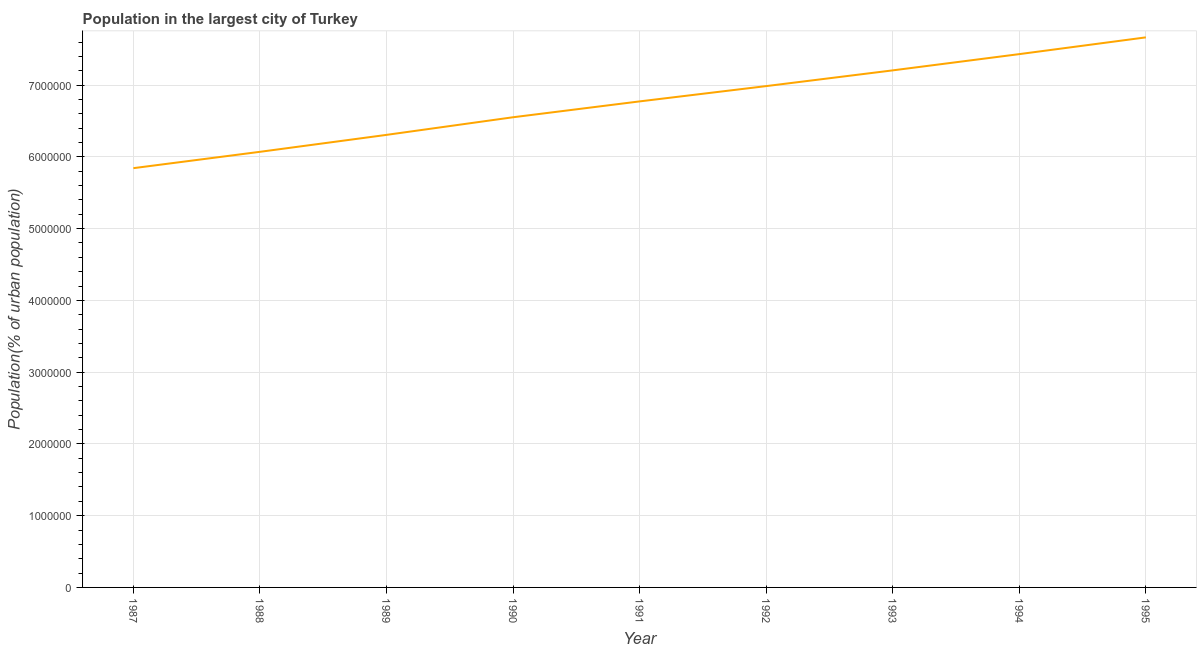What is the population in largest city in 1995?
Your answer should be compact. 7.67e+06. Across all years, what is the maximum population in largest city?
Offer a very short reply. 7.67e+06. Across all years, what is the minimum population in largest city?
Make the answer very short. 5.84e+06. In which year was the population in largest city maximum?
Your answer should be very brief. 1995. In which year was the population in largest city minimum?
Your answer should be very brief. 1987. What is the sum of the population in largest city?
Offer a very short reply. 6.08e+07. What is the difference between the population in largest city in 1990 and 1993?
Offer a very short reply. -6.53e+05. What is the average population in largest city per year?
Your answer should be compact. 6.76e+06. What is the median population in largest city?
Keep it short and to the point. 6.77e+06. Do a majority of the years between 1990 and 1991 (inclusive) have population in largest city greater than 6800000 %?
Ensure brevity in your answer.  No. What is the ratio of the population in largest city in 1992 to that in 1994?
Ensure brevity in your answer.  0.94. Is the difference between the population in largest city in 1988 and 1994 greater than the difference between any two years?
Your response must be concise. No. What is the difference between the highest and the second highest population in largest city?
Ensure brevity in your answer.  2.34e+05. Is the sum of the population in largest city in 1988 and 1993 greater than the maximum population in largest city across all years?
Give a very brief answer. Yes. What is the difference between the highest and the lowest population in largest city?
Your response must be concise. 1.82e+06. In how many years, is the population in largest city greater than the average population in largest city taken over all years?
Give a very brief answer. 5. Does the population in largest city monotonically increase over the years?
Ensure brevity in your answer.  Yes. How many years are there in the graph?
Offer a very short reply. 9. What is the difference between two consecutive major ticks on the Y-axis?
Ensure brevity in your answer.  1.00e+06. Does the graph contain grids?
Offer a very short reply. Yes. What is the title of the graph?
Ensure brevity in your answer.  Population in the largest city of Turkey. What is the label or title of the Y-axis?
Offer a very short reply. Population(% of urban population). What is the Population(% of urban population) in 1987?
Your answer should be compact. 5.84e+06. What is the Population(% of urban population) in 1988?
Offer a very short reply. 6.07e+06. What is the Population(% of urban population) of 1989?
Your answer should be very brief. 6.31e+06. What is the Population(% of urban population) of 1990?
Your response must be concise. 6.55e+06. What is the Population(% of urban population) in 1991?
Provide a succinct answer. 6.77e+06. What is the Population(% of urban population) of 1992?
Your response must be concise. 6.99e+06. What is the Population(% of urban population) of 1993?
Give a very brief answer. 7.21e+06. What is the Population(% of urban population) in 1994?
Provide a short and direct response. 7.43e+06. What is the Population(% of urban population) in 1995?
Your response must be concise. 7.67e+06. What is the difference between the Population(% of urban population) in 1987 and 1988?
Your answer should be very brief. -2.28e+05. What is the difference between the Population(% of urban population) in 1987 and 1989?
Your answer should be very brief. -4.64e+05. What is the difference between the Population(% of urban population) in 1987 and 1990?
Keep it short and to the point. -7.10e+05. What is the difference between the Population(% of urban population) in 1987 and 1991?
Ensure brevity in your answer.  -9.31e+05. What is the difference between the Population(% of urban population) in 1987 and 1992?
Your answer should be very brief. -1.14e+06. What is the difference between the Population(% of urban population) in 1987 and 1993?
Make the answer very short. -1.36e+06. What is the difference between the Population(% of urban population) in 1987 and 1994?
Offer a very short reply. -1.59e+06. What is the difference between the Population(% of urban population) in 1987 and 1995?
Provide a short and direct response. -1.82e+06. What is the difference between the Population(% of urban population) in 1988 and 1989?
Give a very brief answer. -2.36e+05. What is the difference between the Population(% of urban population) in 1988 and 1990?
Make the answer very short. -4.82e+05. What is the difference between the Population(% of urban population) in 1988 and 1991?
Your answer should be very brief. -7.03e+05. What is the difference between the Population(% of urban population) in 1988 and 1992?
Ensure brevity in your answer.  -9.16e+05. What is the difference between the Population(% of urban population) in 1988 and 1993?
Ensure brevity in your answer.  -1.14e+06. What is the difference between the Population(% of urban population) in 1988 and 1994?
Provide a succinct answer. -1.36e+06. What is the difference between the Population(% of urban population) in 1988 and 1995?
Keep it short and to the point. -1.59e+06. What is the difference between the Population(% of urban population) in 1989 and 1990?
Your answer should be very brief. -2.46e+05. What is the difference between the Population(% of urban population) in 1989 and 1991?
Keep it short and to the point. -4.67e+05. What is the difference between the Population(% of urban population) in 1989 and 1992?
Offer a terse response. -6.80e+05. What is the difference between the Population(% of urban population) in 1989 and 1993?
Keep it short and to the point. -8.99e+05. What is the difference between the Population(% of urban population) in 1989 and 1994?
Your answer should be compact. -1.13e+06. What is the difference between the Population(% of urban population) in 1989 and 1995?
Give a very brief answer. -1.36e+06. What is the difference between the Population(% of urban population) in 1990 and 1991?
Your answer should be very brief. -2.21e+05. What is the difference between the Population(% of urban population) in 1990 and 1992?
Ensure brevity in your answer.  -4.34e+05. What is the difference between the Population(% of urban population) in 1990 and 1993?
Ensure brevity in your answer.  -6.53e+05. What is the difference between the Population(% of urban population) in 1990 and 1994?
Your answer should be very brief. -8.80e+05. What is the difference between the Population(% of urban population) in 1990 and 1995?
Offer a terse response. -1.11e+06. What is the difference between the Population(% of urban population) in 1991 and 1992?
Provide a short and direct response. -2.13e+05. What is the difference between the Population(% of urban population) in 1991 and 1993?
Make the answer very short. -4.32e+05. What is the difference between the Population(% of urban population) in 1991 and 1994?
Your answer should be compact. -6.59e+05. What is the difference between the Population(% of urban population) in 1991 and 1995?
Your response must be concise. -8.92e+05. What is the difference between the Population(% of urban population) in 1992 and 1993?
Provide a short and direct response. -2.19e+05. What is the difference between the Population(% of urban population) in 1992 and 1994?
Ensure brevity in your answer.  -4.46e+05. What is the difference between the Population(% of urban population) in 1992 and 1995?
Keep it short and to the point. -6.79e+05. What is the difference between the Population(% of urban population) in 1993 and 1994?
Make the answer very short. -2.26e+05. What is the difference between the Population(% of urban population) in 1993 and 1995?
Your answer should be compact. -4.60e+05. What is the difference between the Population(% of urban population) in 1994 and 1995?
Make the answer very short. -2.34e+05. What is the ratio of the Population(% of urban population) in 1987 to that in 1989?
Make the answer very short. 0.93. What is the ratio of the Population(% of urban population) in 1987 to that in 1990?
Offer a very short reply. 0.89. What is the ratio of the Population(% of urban population) in 1987 to that in 1991?
Give a very brief answer. 0.86. What is the ratio of the Population(% of urban population) in 1987 to that in 1992?
Your answer should be compact. 0.84. What is the ratio of the Population(% of urban population) in 1987 to that in 1993?
Your answer should be very brief. 0.81. What is the ratio of the Population(% of urban population) in 1987 to that in 1994?
Offer a very short reply. 0.79. What is the ratio of the Population(% of urban population) in 1987 to that in 1995?
Make the answer very short. 0.76. What is the ratio of the Population(% of urban population) in 1988 to that in 1989?
Provide a succinct answer. 0.96. What is the ratio of the Population(% of urban population) in 1988 to that in 1990?
Make the answer very short. 0.93. What is the ratio of the Population(% of urban population) in 1988 to that in 1991?
Your answer should be very brief. 0.9. What is the ratio of the Population(% of urban population) in 1988 to that in 1992?
Keep it short and to the point. 0.87. What is the ratio of the Population(% of urban population) in 1988 to that in 1993?
Keep it short and to the point. 0.84. What is the ratio of the Population(% of urban population) in 1988 to that in 1994?
Offer a very short reply. 0.82. What is the ratio of the Population(% of urban population) in 1988 to that in 1995?
Provide a succinct answer. 0.79. What is the ratio of the Population(% of urban population) in 1989 to that in 1990?
Provide a short and direct response. 0.96. What is the ratio of the Population(% of urban population) in 1989 to that in 1991?
Ensure brevity in your answer.  0.93. What is the ratio of the Population(% of urban population) in 1989 to that in 1992?
Offer a very short reply. 0.9. What is the ratio of the Population(% of urban population) in 1989 to that in 1993?
Provide a short and direct response. 0.88. What is the ratio of the Population(% of urban population) in 1989 to that in 1994?
Offer a terse response. 0.85. What is the ratio of the Population(% of urban population) in 1989 to that in 1995?
Make the answer very short. 0.82. What is the ratio of the Population(% of urban population) in 1990 to that in 1992?
Make the answer very short. 0.94. What is the ratio of the Population(% of urban population) in 1990 to that in 1993?
Ensure brevity in your answer.  0.91. What is the ratio of the Population(% of urban population) in 1990 to that in 1994?
Offer a very short reply. 0.88. What is the ratio of the Population(% of urban population) in 1990 to that in 1995?
Keep it short and to the point. 0.85. What is the ratio of the Population(% of urban population) in 1991 to that in 1994?
Keep it short and to the point. 0.91. What is the ratio of the Population(% of urban population) in 1991 to that in 1995?
Your answer should be very brief. 0.88. What is the ratio of the Population(% of urban population) in 1992 to that in 1993?
Provide a succinct answer. 0.97. What is the ratio of the Population(% of urban population) in 1992 to that in 1995?
Provide a succinct answer. 0.91. What is the ratio of the Population(% of urban population) in 1993 to that in 1994?
Offer a very short reply. 0.97. What is the ratio of the Population(% of urban population) in 1993 to that in 1995?
Offer a very short reply. 0.94. What is the ratio of the Population(% of urban population) in 1994 to that in 1995?
Your answer should be compact. 0.97. 